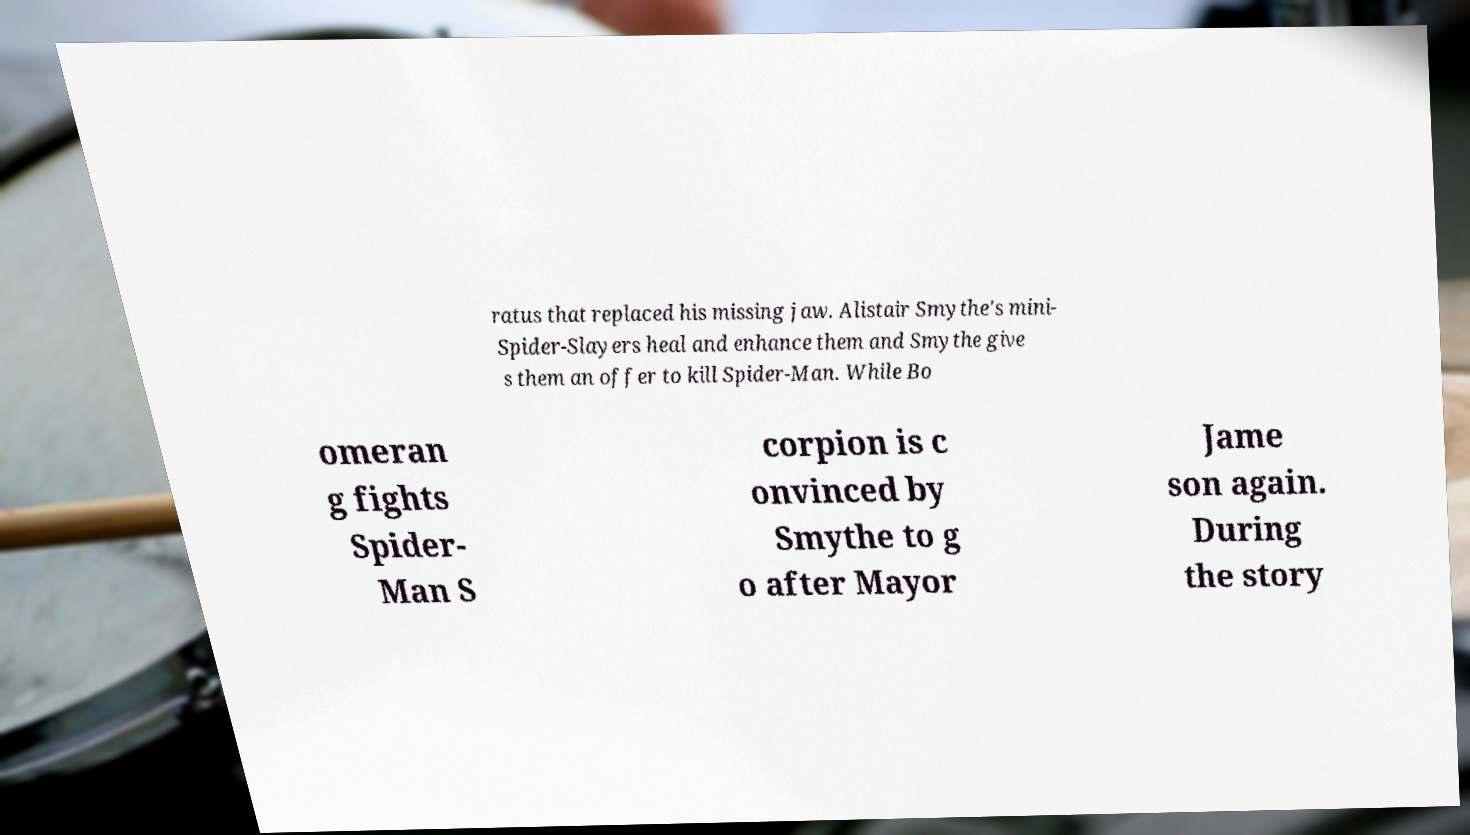Can you read and provide the text displayed in the image?This photo seems to have some interesting text. Can you extract and type it out for me? ratus that replaced his missing jaw. Alistair Smythe's mini- Spider-Slayers heal and enhance them and Smythe give s them an offer to kill Spider-Man. While Bo omeran g fights Spider- Man S corpion is c onvinced by Smythe to g o after Mayor Jame son again. During the story 